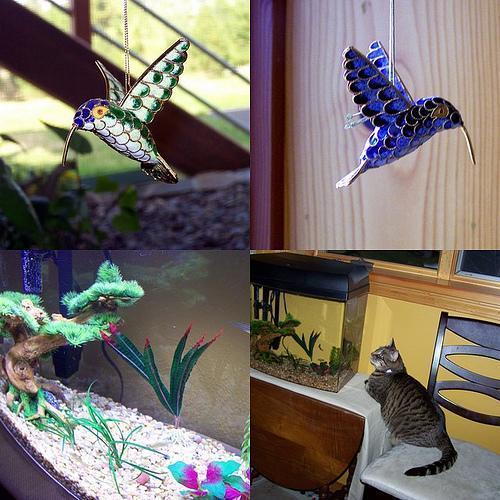How many cats are there?
Give a very brief answer. 1. 